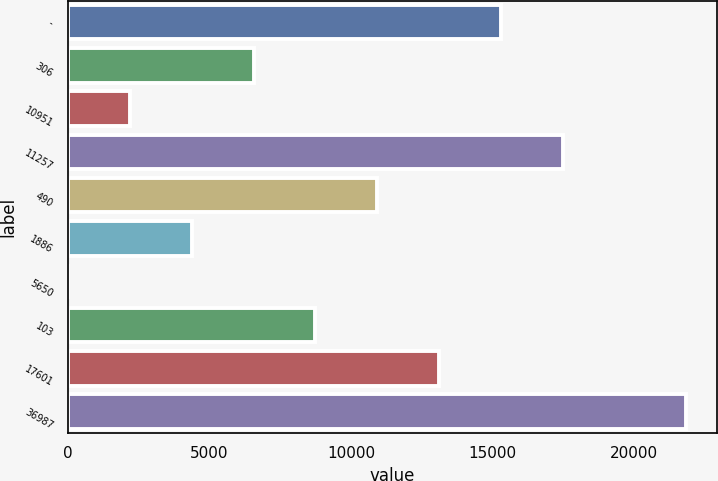Convert chart. <chart><loc_0><loc_0><loc_500><loc_500><bar_chart><fcel>-<fcel>306<fcel>10951<fcel>11257<fcel>490<fcel>1886<fcel>5650<fcel>103<fcel>17601<fcel>36987<nl><fcel>15294.9<fcel>6568.1<fcel>2204.7<fcel>17476.6<fcel>10931.5<fcel>4386.4<fcel>23<fcel>8749.8<fcel>13113.2<fcel>21840<nl></chart> 